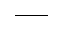<formula> <loc_0><loc_0><loc_500><loc_500>\_</formula> 